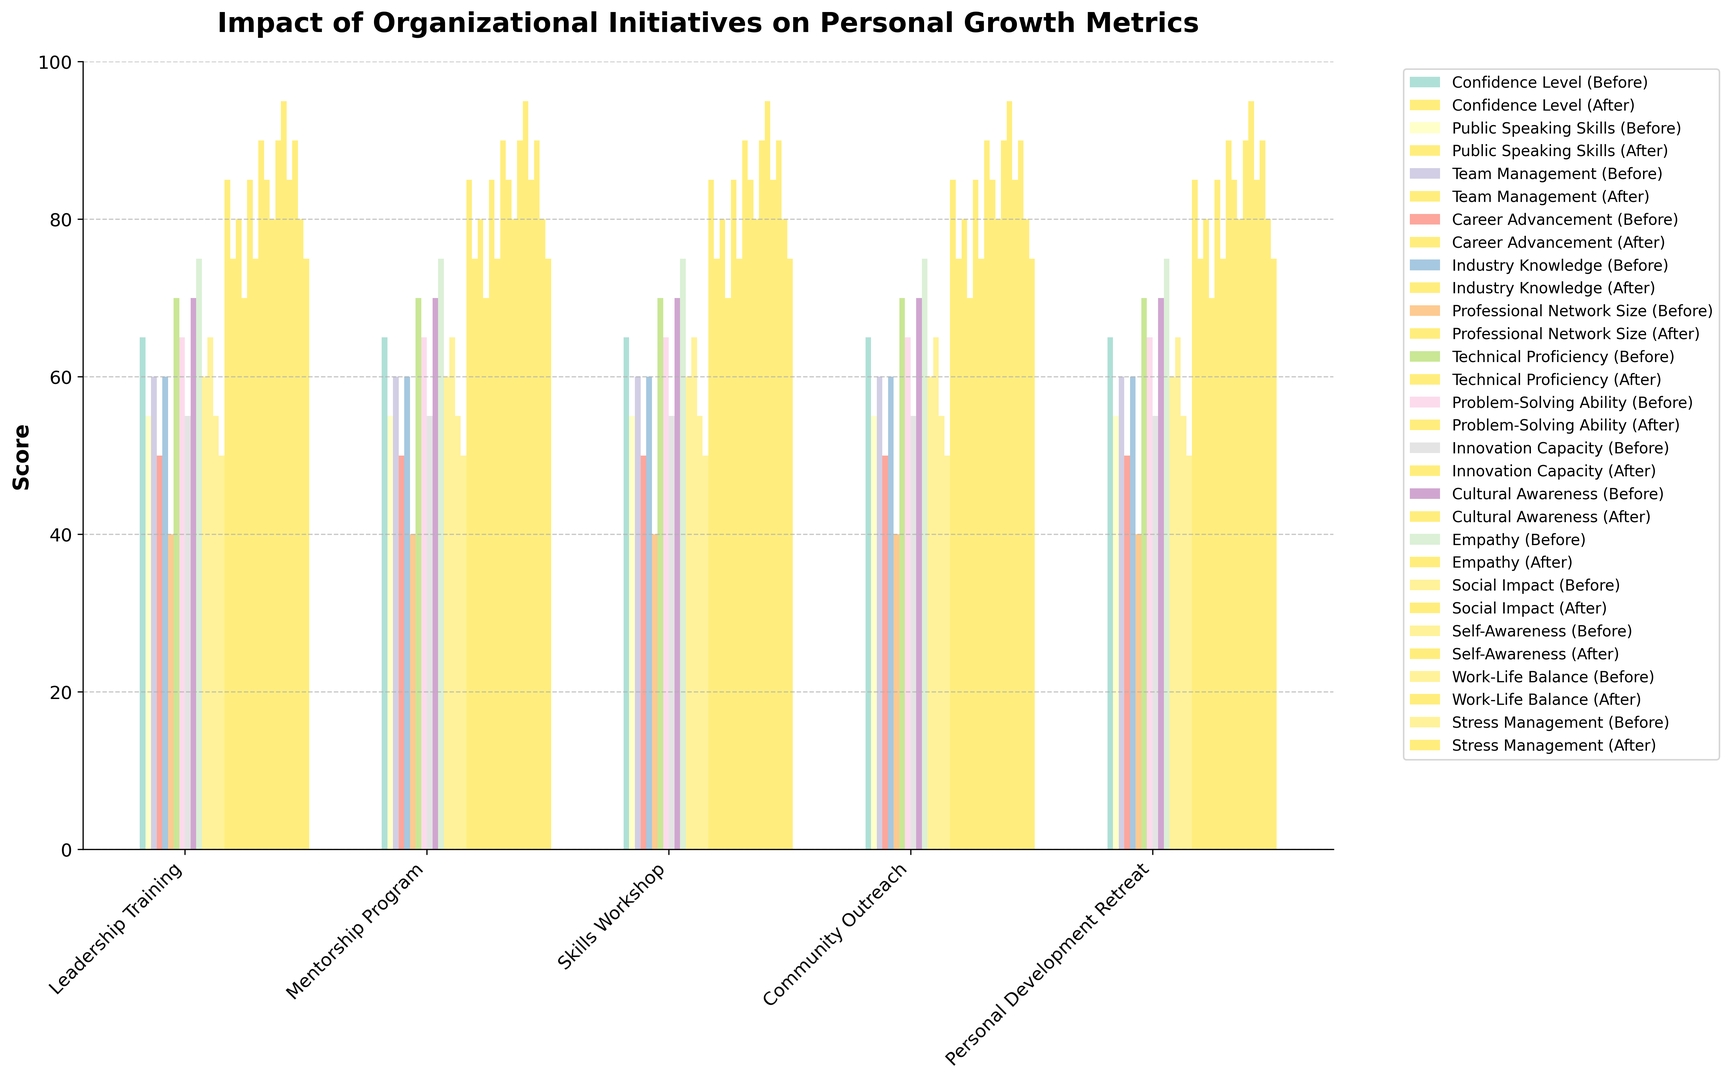What's the average improvement in Confidence Level after the Leadership Training initiative? First, we find the 'Before' and 'After' values for Confidence Level within the Leadership Training initiative which are 65 and 85 respectively. The difference is (85 - 65) = 20. Then, we determine the average change = 20.
Answer: 20 Which initiative showed the greatest improvement in Public Speaking Skills? Look at the 'Before' and 'After' values for Public Speaking Skills across different initiatives. Leadership Training has 'Before' = 55 and 'After' = 75. This is the only initiative for this metric, meaning it has the greatest improvement of 20.
Answer: Leadership Training Which metric had the highest improvement in the Mentorship Program? Examine all metrics under the Mentorship Program and their 'Before' and 'After' values. Career Advancement improved from 50 to 70 (20), Industry Knowledge from 60 to 85 (25), and Professional Network Size from 40 to 75 (35). The highest improvement is 35.
Answer: Professional Network Size Compare the improvement in Team Management from the Leadership Training initiative to Stress Management from the Personal Development Retreat. Which one had a greater improvement? Check 'Before' and 'After' values for both metrics. Team Management improved from 60 to 80, a change of 20. Stress Management improved from 50 to 75, a change of 25. Thus, Stress Management had a greater improvement.
Answer: Stress Management Identify which initiative had the lowest initial value across all metrics. Look for the lowest 'Before' value in the dataset. The lowest value is 40 for Professional Network Size in the Mentorship Program initiative.
Answer: Mentorship Program How does the Post-Training Confidence Level compare to the Pre-Training Cultural Awareness? Compare the ‘After’ value for Confidence Level (85) with the ‘Before’ value for Cultural Awareness (70). 85 (Confidence Level) is greater than 70 (Cultural Awareness).
Answer: Confidence Level is higher What is the total improvement in Innovation Capacity and Problem-Solving Ability after the Skills Workshop? Find the 'Before' and 'After' values for Innovation Capacity (55 to 80, a difference of 25) and Problem-Solving Ability (65 to 85, a difference of 20). Add the improvements: 25 + 20 = 45.
Answer: 45 By how much did Cultural Awareness improve post Community Outreach? Look at the 'Before' and 'After' values for Cultural Awareness under Community Outreach. The values are 70 and 90 respectively. The difference is 90 - 70 = 20.
Answer: 20 List the initiatives that resulted in more than 20-point improvement in any metric. Identify metrics with improvements over 20 points and note their initiatives: 
- Leadership Training: Confidence Level (20).
- Mentorship Program: Industry Knowledge (25), Professional Network Size (35).
- Skills Workshop: Technical Proficiency (20), Problem-Solving Ability (20), Innovation Capacity (25).
- Community Outreach: Cultural Awareness (20), Empathy (20), Social Impact (25).
- Personal Development Retreat: Self-Awareness (25).
Answer: Mentorship Program, Skills Workshop, Community Outreach, Personal Development Retreat 